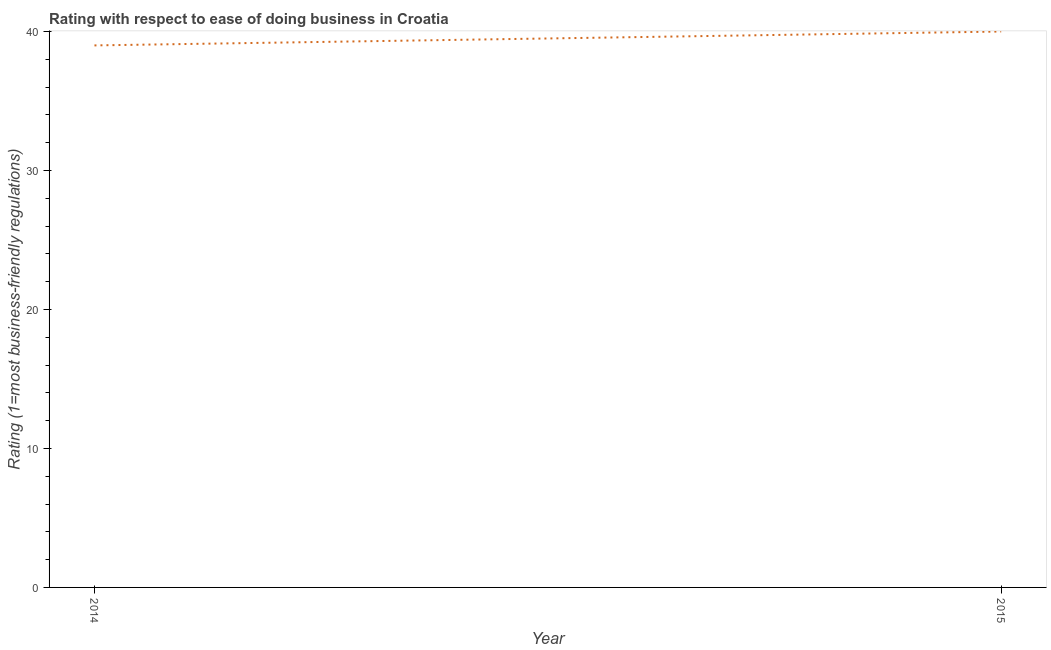What is the ease of doing business index in 2015?
Give a very brief answer. 40. Across all years, what is the maximum ease of doing business index?
Provide a succinct answer. 40. Across all years, what is the minimum ease of doing business index?
Give a very brief answer. 39. In which year was the ease of doing business index maximum?
Provide a short and direct response. 2015. What is the sum of the ease of doing business index?
Provide a short and direct response. 79. What is the difference between the ease of doing business index in 2014 and 2015?
Offer a terse response. -1. What is the average ease of doing business index per year?
Your answer should be compact. 39.5. What is the median ease of doing business index?
Give a very brief answer. 39.5. Do a majority of the years between 2015 and 2014 (inclusive) have ease of doing business index greater than 18 ?
Give a very brief answer. No. What is the ratio of the ease of doing business index in 2014 to that in 2015?
Provide a short and direct response. 0.97. Does the ease of doing business index monotonically increase over the years?
Provide a short and direct response. Yes. How many lines are there?
Offer a very short reply. 1. What is the difference between two consecutive major ticks on the Y-axis?
Keep it short and to the point. 10. What is the title of the graph?
Your answer should be compact. Rating with respect to ease of doing business in Croatia. What is the label or title of the X-axis?
Offer a very short reply. Year. What is the label or title of the Y-axis?
Provide a succinct answer. Rating (1=most business-friendly regulations). What is the Rating (1=most business-friendly regulations) in 2014?
Your answer should be compact. 39. What is the Rating (1=most business-friendly regulations) in 2015?
Offer a terse response. 40. What is the difference between the Rating (1=most business-friendly regulations) in 2014 and 2015?
Ensure brevity in your answer.  -1. 